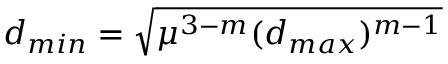<formula> <loc_0><loc_0><loc_500><loc_500>d _ { \min } = \sqrt { \mu ^ { 3 - m } ( d _ { \max } ) ^ { m - 1 } }</formula> 